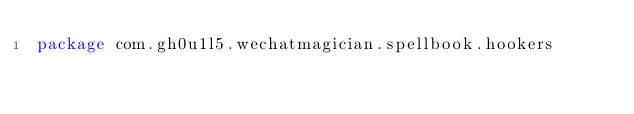Convert code to text. <code><loc_0><loc_0><loc_500><loc_500><_Kotlin_>package com.gh0u1l5.wechatmagician.spellbook.hookers
</code> 